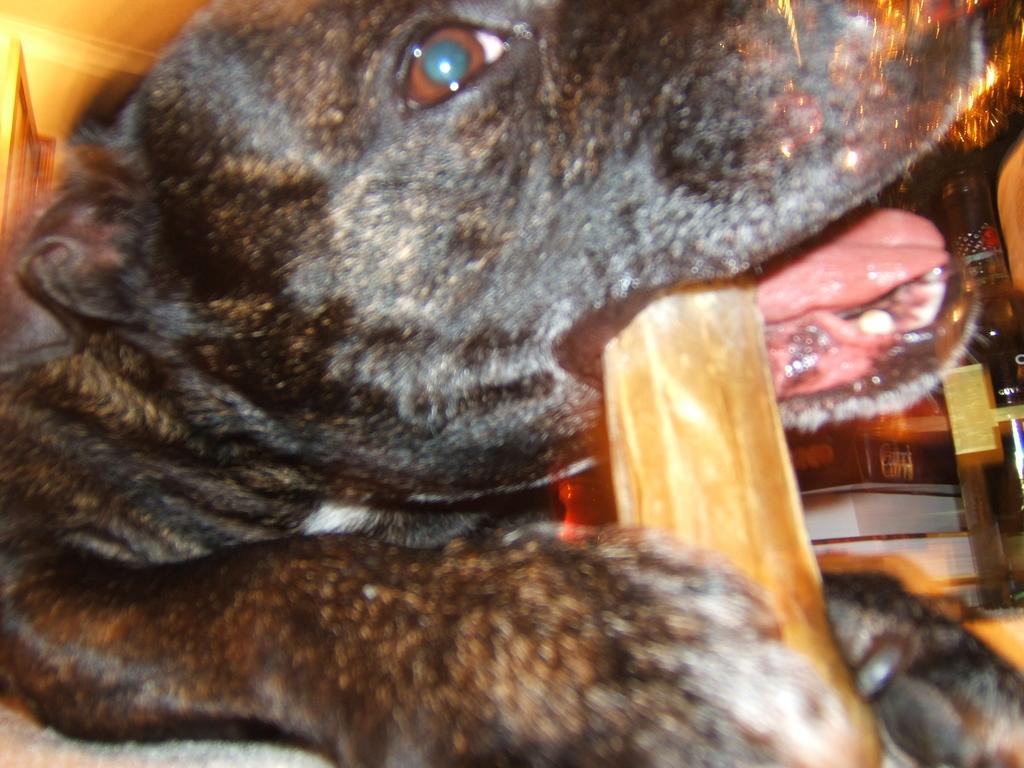What type of animal is present in the image? There is a dog in the image. What is the dog doing in the image? The dog is holding an object in its mouth. What can be seen on the right side of the image? There is a chair on the right side of the image. What else is visible in the image besides the dog and chair? There are books in the image. What type of ornament is the dog wearing around its neck in the image? There is no ornament visible around the dog's neck in the image. What holiday is being celebrated in the image? There is no indication of a holiday being celebrated in the image. 